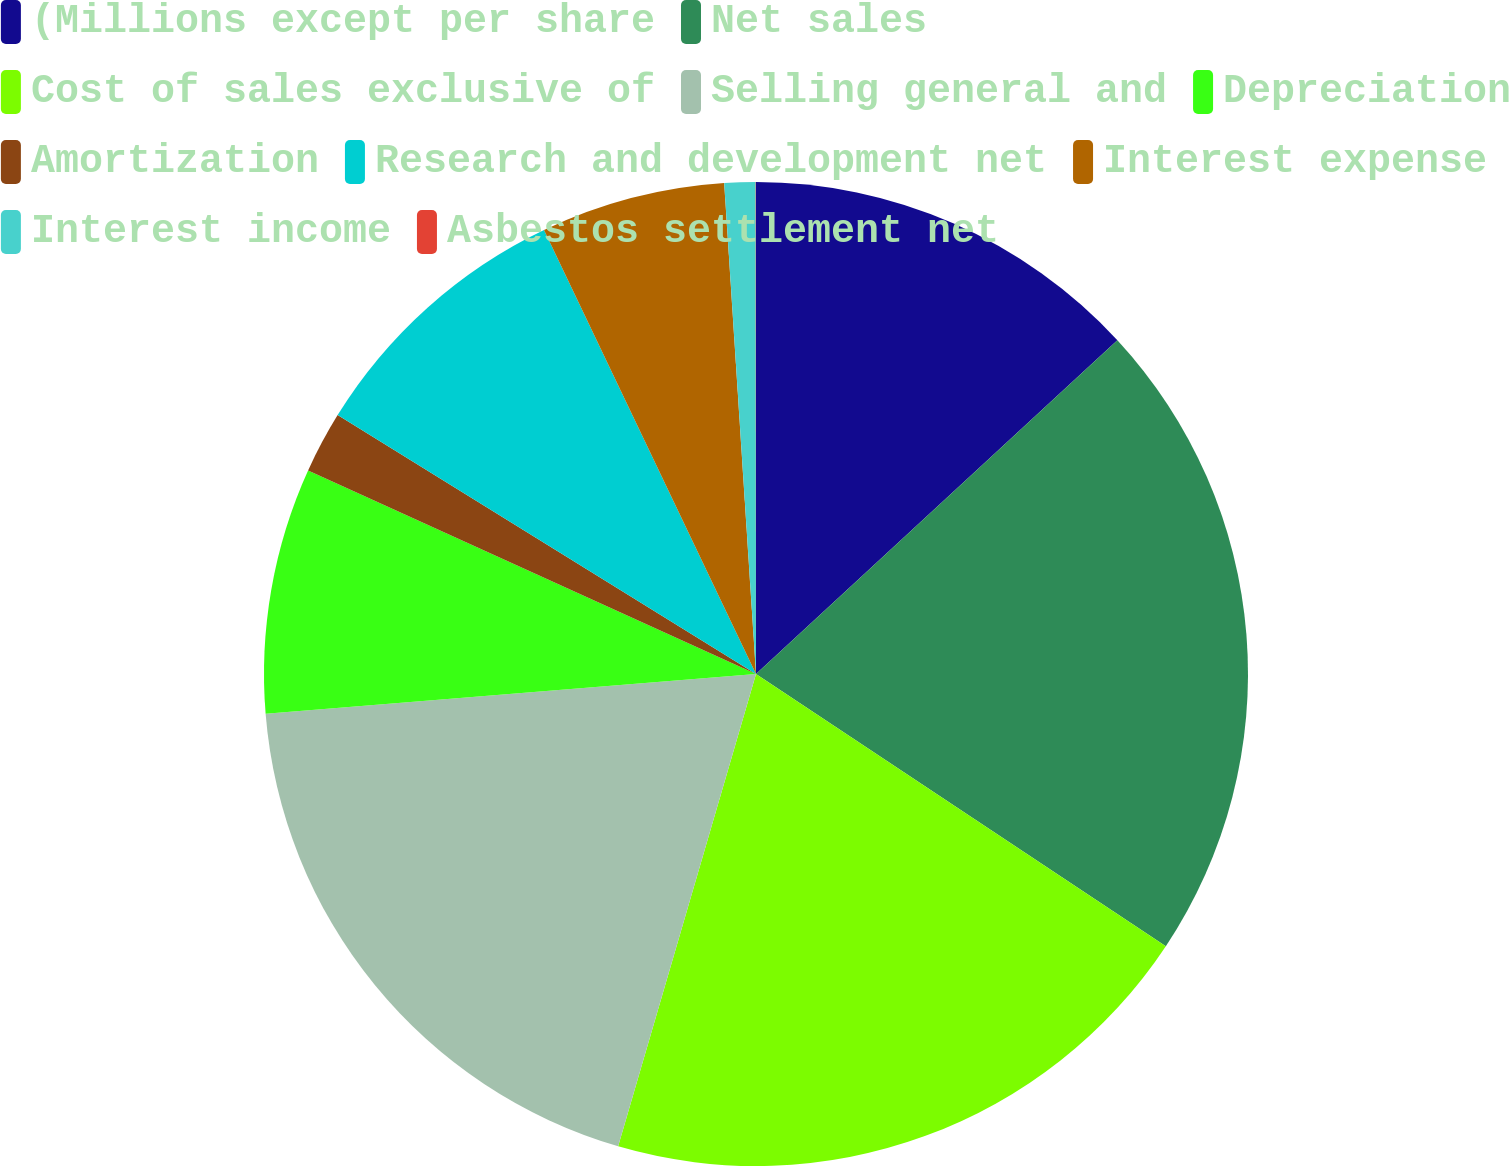<chart> <loc_0><loc_0><loc_500><loc_500><pie_chart><fcel>(Millions except per share<fcel>Net sales<fcel>Cost of sales exclusive of<fcel>Selling general and<fcel>Depreciation<fcel>Amortization<fcel>Research and development net<fcel>Interest expense<fcel>Interest income<fcel>Asbestos settlement net<nl><fcel>13.13%<fcel>21.2%<fcel>20.19%<fcel>19.19%<fcel>8.08%<fcel>2.03%<fcel>9.09%<fcel>6.06%<fcel>1.02%<fcel>0.01%<nl></chart> 